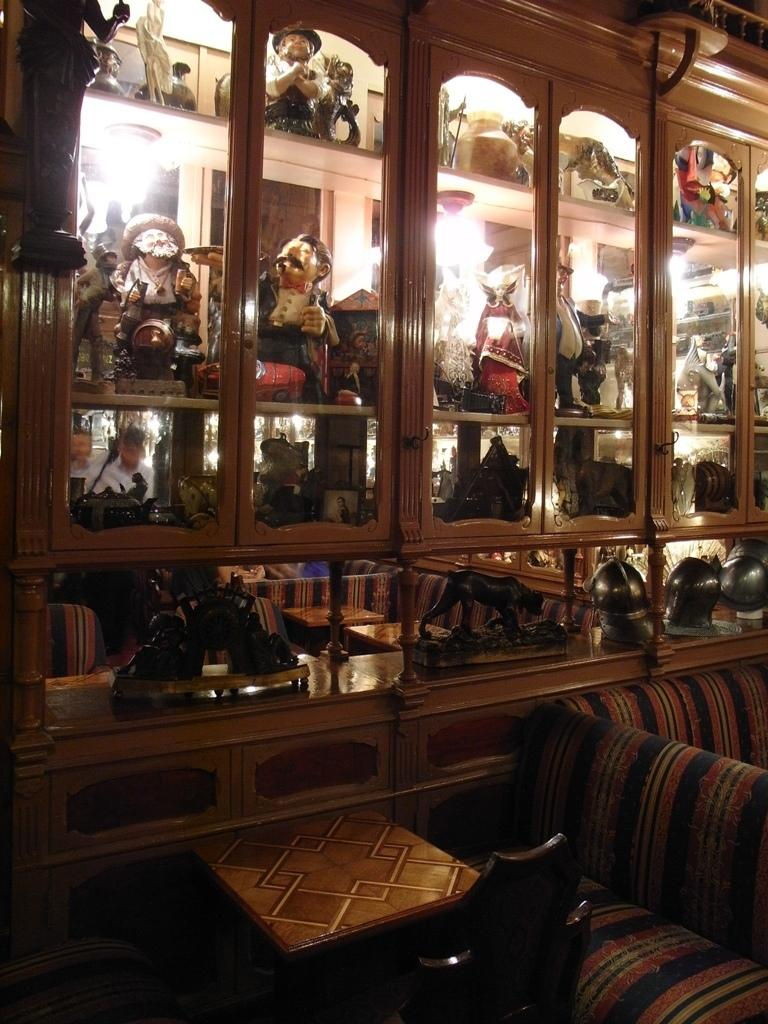What type of furniture is present in the image? There is a table and a couch in the image. What else can be seen in the image besides the furniture? There is a rack full of toys in the image. What type of current can be seen flowing through the toys in the image? There is no current visible in the image, as it is not related to electricity or water flow. 